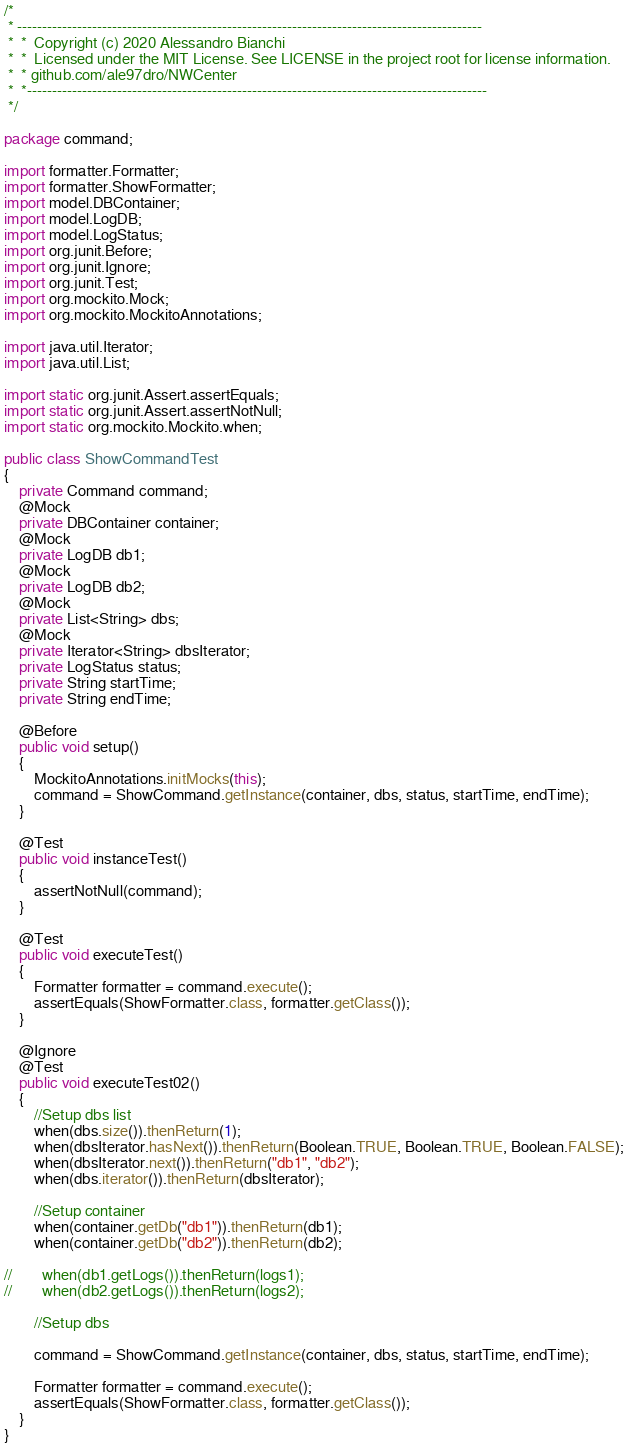<code> <loc_0><loc_0><loc_500><loc_500><_Java_>/*
 * ---------------------------------------------------------------------------------------------
 *  *  Copyright (c) 2020 Alessandro Bianchi
 *  *  Licensed under the MIT License. See LICENSE in the project root for license information.
 *  * github.com/ale97dro/NWCenter
 *  *--------------------------------------------------------------------------------------------
 */

package command;

import formatter.Formatter;
import formatter.ShowFormatter;
import model.DBContainer;
import model.LogDB;
import model.LogStatus;
import org.junit.Before;
import org.junit.Ignore;
import org.junit.Test;
import org.mockito.Mock;
import org.mockito.MockitoAnnotations;

import java.util.Iterator;
import java.util.List;

import static org.junit.Assert.assertEquals;
import static org.junit.Assert.assertNotNull;
import static org.mockito.Mockito.when;

public class ShowCommandTest
{
    private Command command;
    @Mock
    private DBContainer container;
    @Mock
    private LogDB db1;
    @Mock
    private LogDB db2;
    @Mock
    private List<String> dbs;
    @Mock
    private Iterator<String> dbsIterator;
    private LogStatus status;
    private String startTime;
    private String endTime;

    @Before
    public void setup()
    {
        MockitoAnnotations.initMocks(this);
        command = ShowCommand.getInstance(container, dbs, status, startTime, endTime);
    }

    @Test
    public void instanceTest()
    {
        assertNotNull(command);
    }

    @Test
    public void executeTest()
    {
        Formatter formatter = command.execute();
        assertEquals(ShowFormatter.class, formatter.getClass());
    }

    @Ignore
    @Test
    public void executeTest02()
    {
        //Setup dbs list
        when(dbs.size()).thenReturn(1);
        when(dbsIterator.hasNext()).thenReturn(Boolean.TRUE, Boolean.TRUE, Boolean.FALSE);
        when(dbsIterator.next()).thenReturn("db1", "db2");
        when(dbs.iterator()).thenReturn(dbsIterator);

        //Setup container
        when(container.getDb("db1")).thenReturn(db1);
        when(container.getDb("db2")).thenReturn(db2);

//        when(db1.getLogs()).thenReturn(logs1);
//        when(db2.getLogs()).thenReturn(logs2);

        //Setup dbs

        command = ShowCommand.getInstance(container, dbs, status, startTime, endTime);

        Formatter formatter = command.execute();
        assertEquals(ShowFormatter.class, formatter.getClass());
    }
}
</code> 